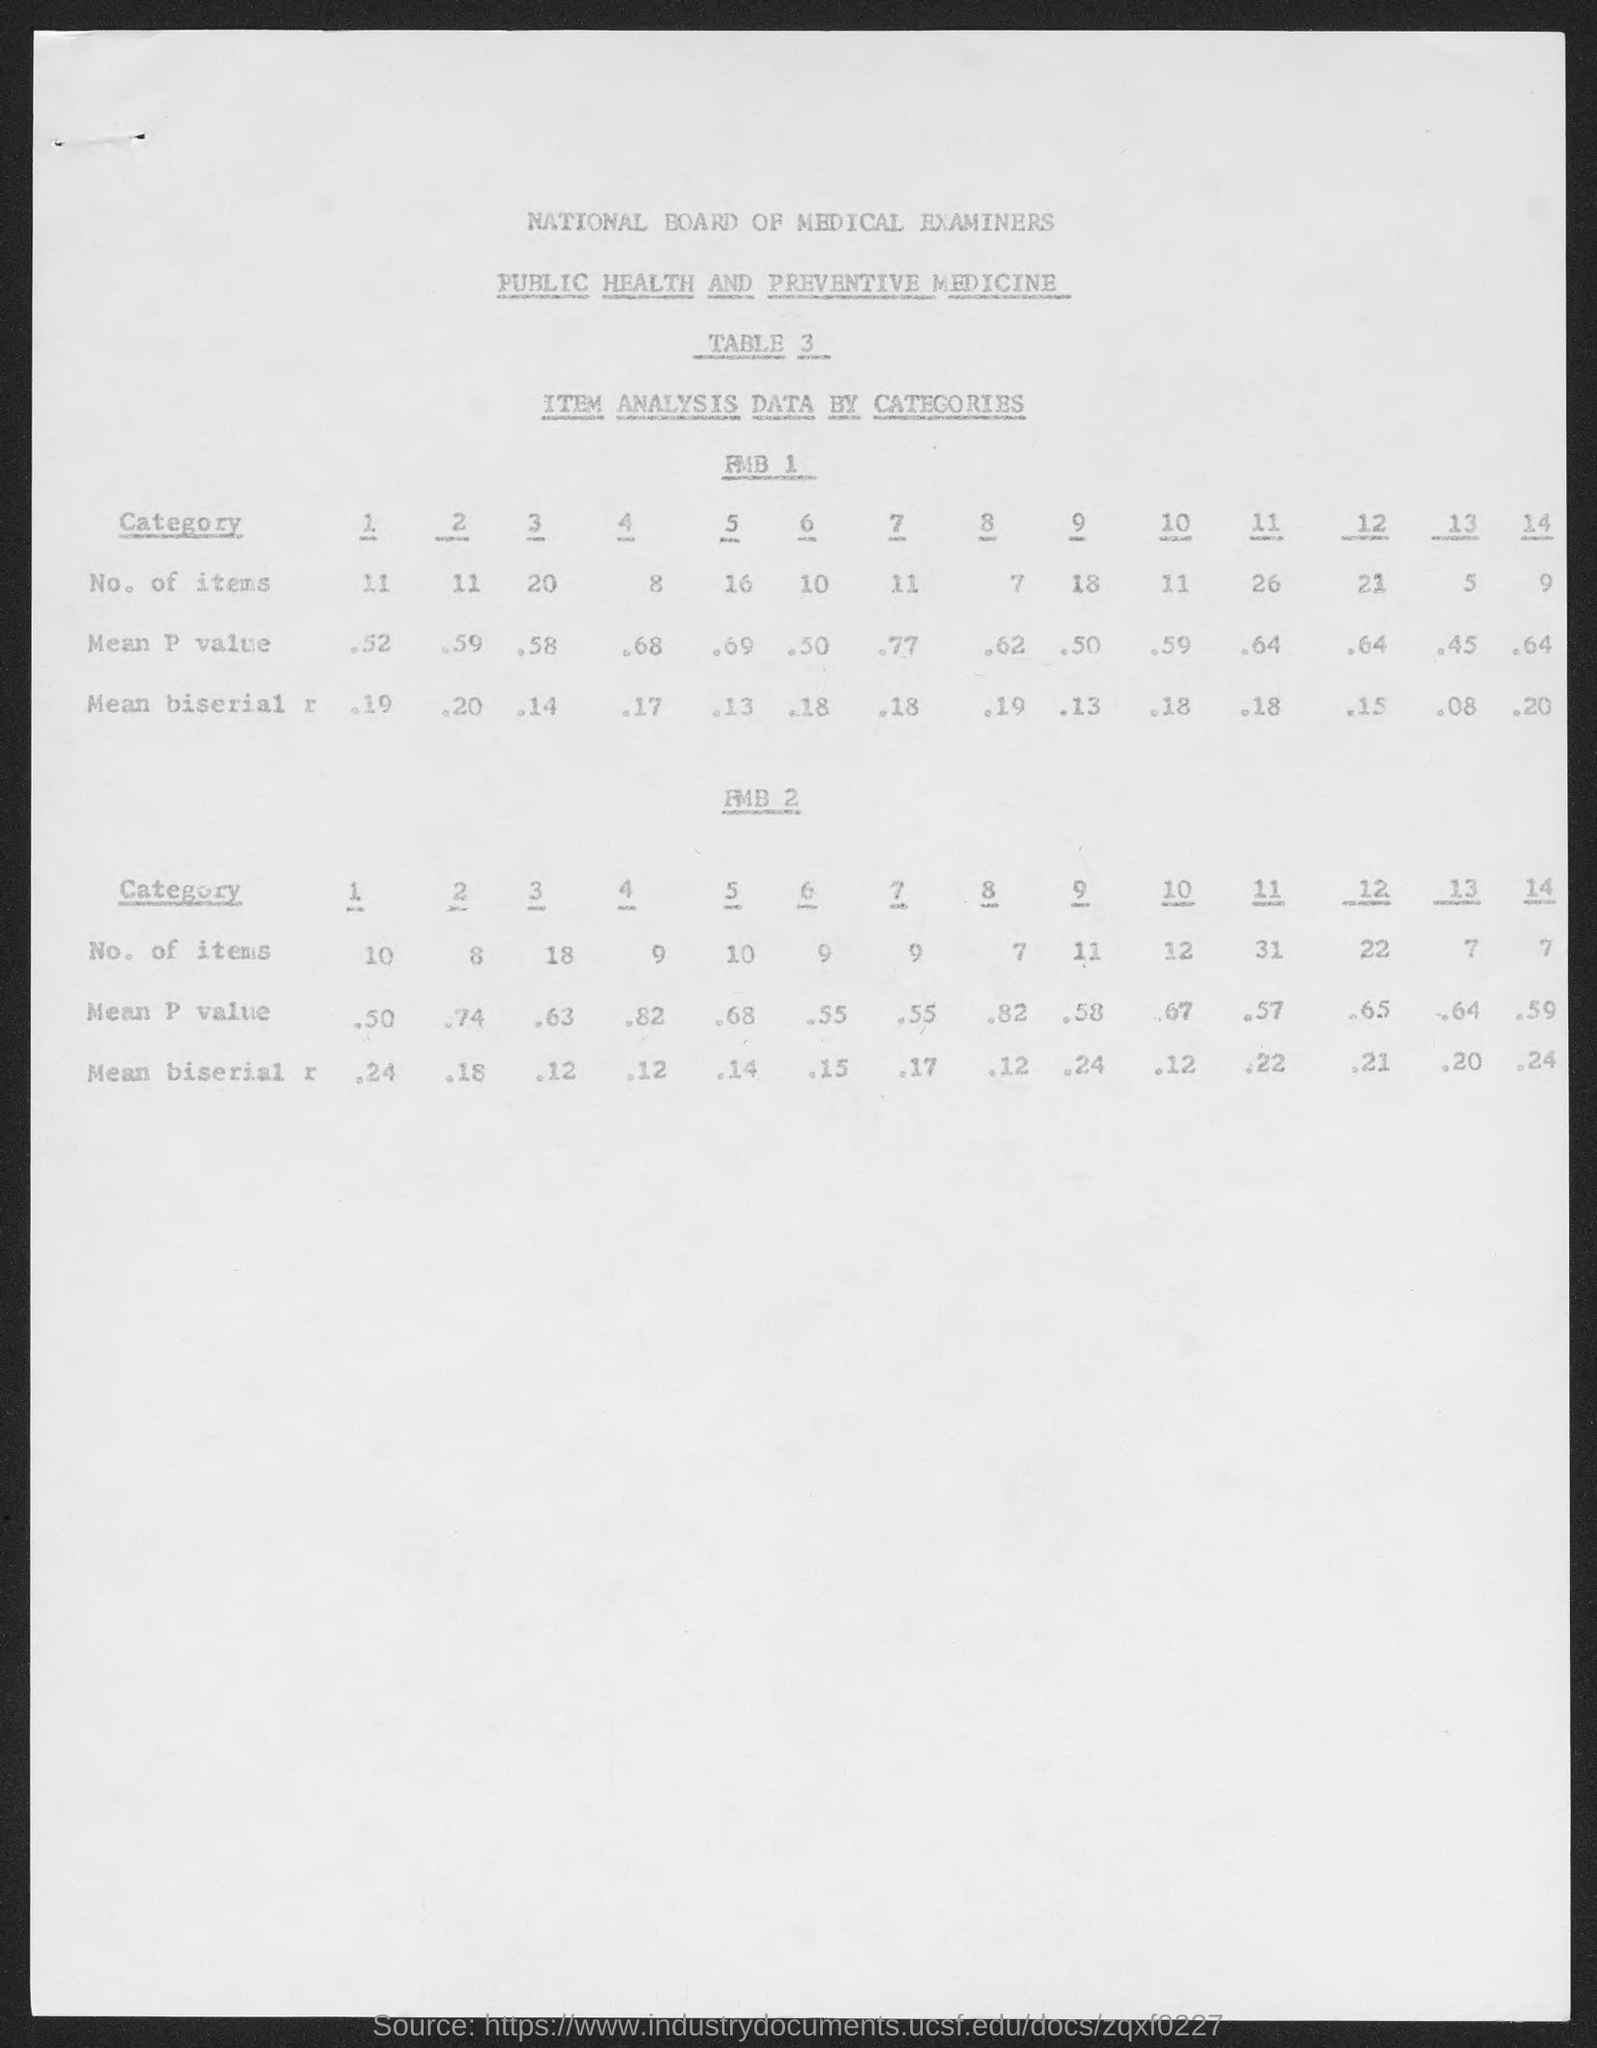What board is it?
Provide a succinct answer. National board of medical examiners. 